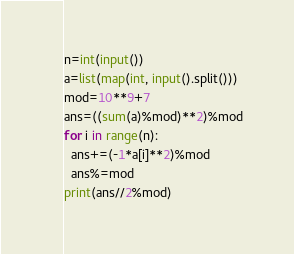Convert code to text. <code><loc_0><loc_0><loc_500><loc_500><_Python_>n=int(input())
a=list(map(int, input().split()))
mod=10**9+7
ans=((sum(a)%mod)**2)%mod
for i in range(n):
  ans+=(-1*a[i]**2)%mod
  ans%=mod
print(ans//2%mod)</code> 